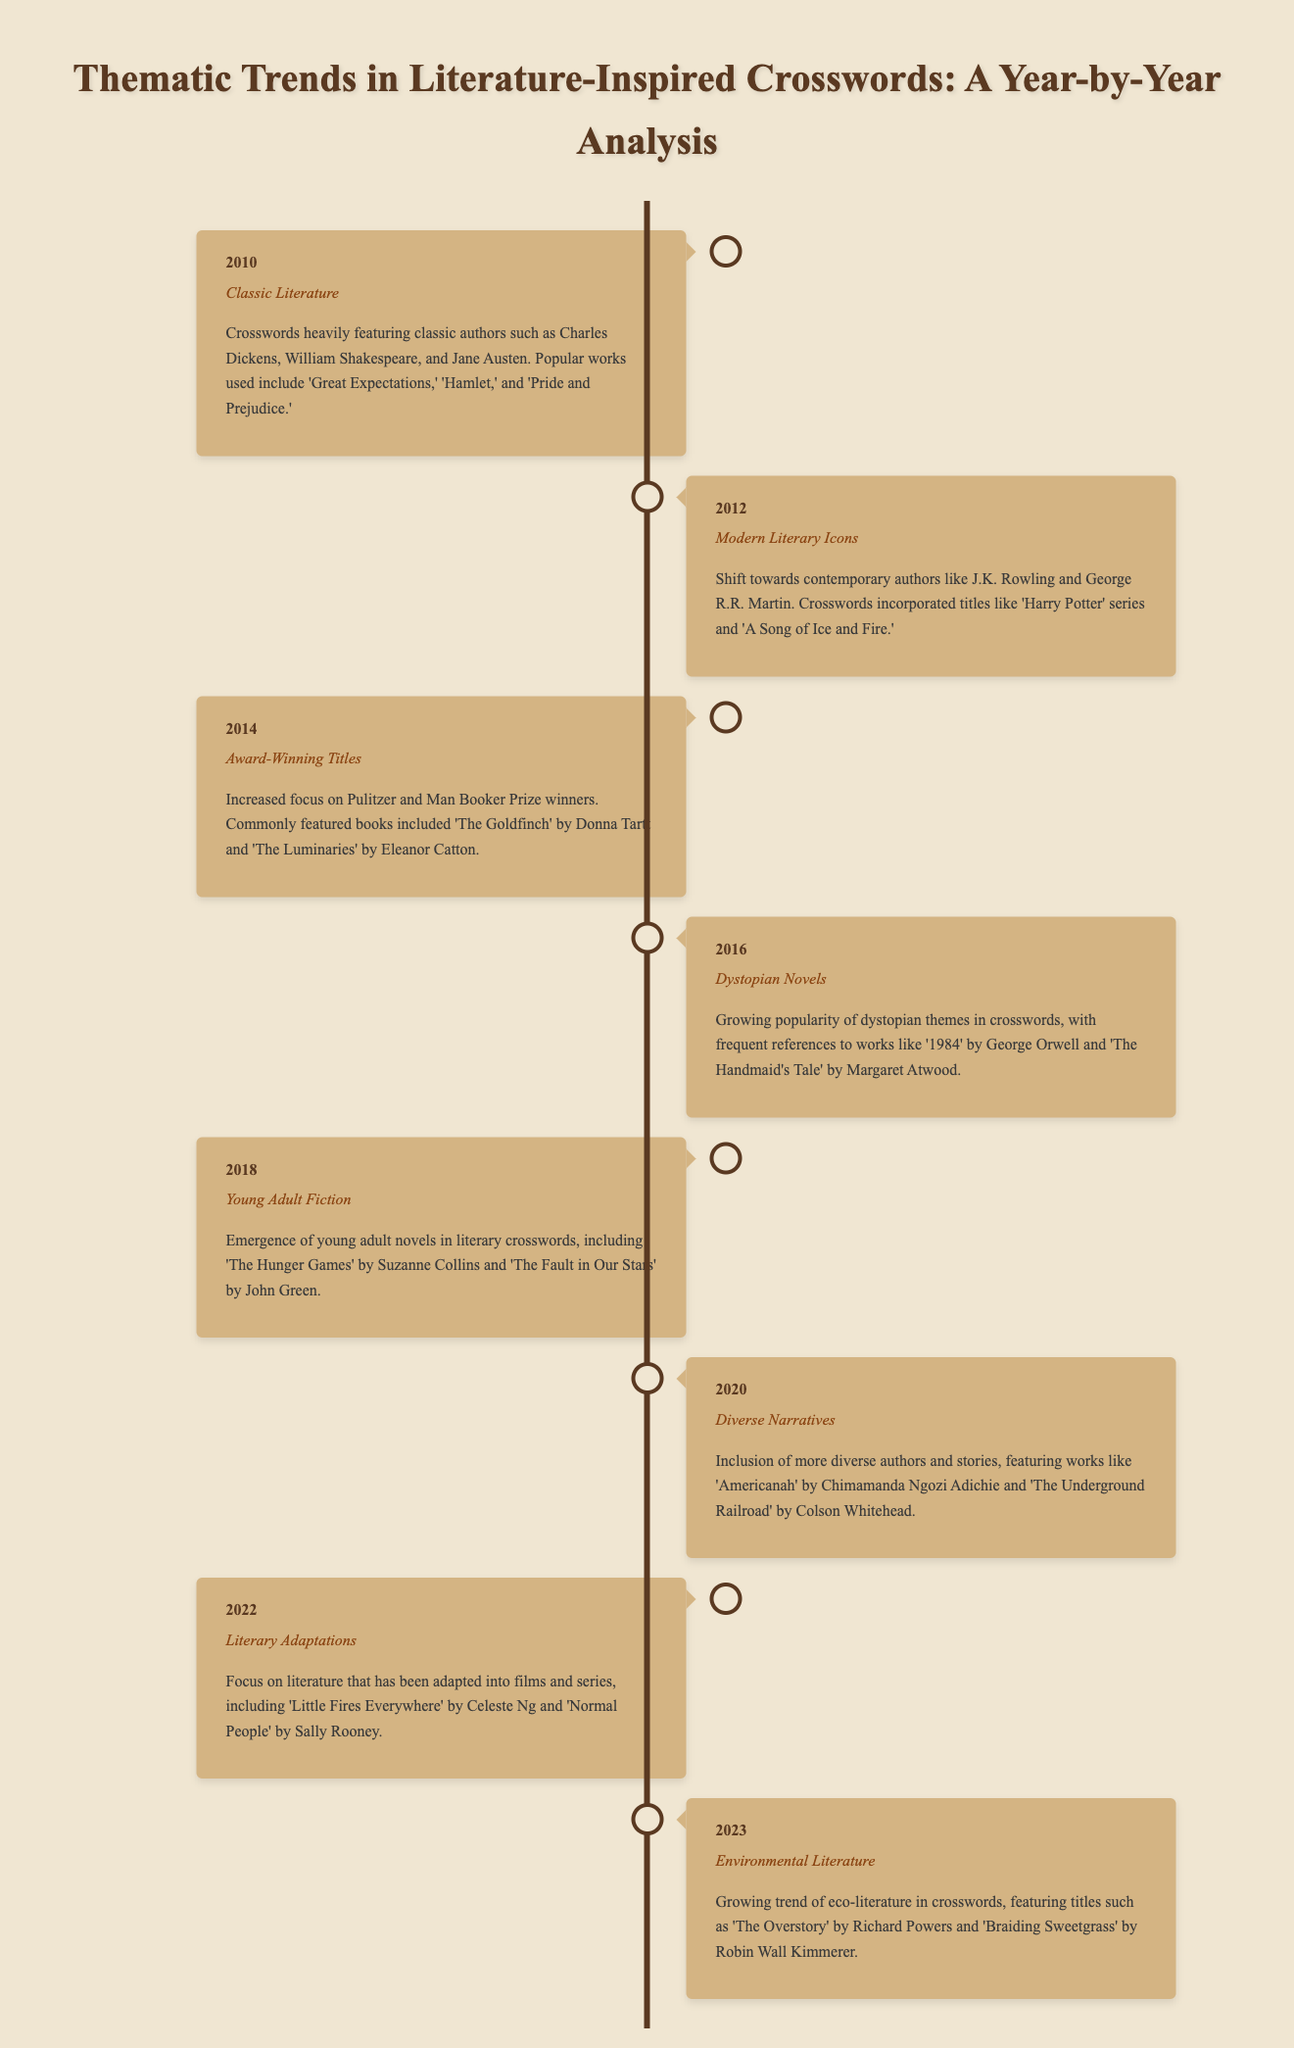What literary trend was highlighted in 2010? The document states that the trend in 2010 was focused on classic authors, with specific examples provided.
Answer: Classic Literature Which author was a focus in the 2012 crossword themes? The timeline indicates a shift towards contemporary authors, with specific references made to one of them.
Answer: J.K. Rowling What significant literary theme emerged in 2018? The document outlines that young adult novels gained prominence in crossword puzzles in 2018, indicating a specific genre focus.
Answer: Young Adult Fiction In what year did the trend of Dystopian Novels become prominent? The given document details the year when Dystopian Novels were a key focus in crosswords.
Answer: 2016 What type of literature was emphasized in 2020? The document explicitly mentions the focus on diverse narrative themes in crosswords during this year.
Answer: Diverse Narratives Which book is associated with the trend of Environmental Literature in 2023? The timeline references specific titles that relate to the growing theme of eco-literature for that year.
Answer: The Overstory How many years does the timeline cover? A count of the different years listed in the timeline reveals the span of years covered.
Answer: 8 What literary genre started to appear in crosswords around 2014? The document specifies a shift towards recognizing award-winning works, indicating a genre within that timeframe.
Answer: Award-Winning Titles 